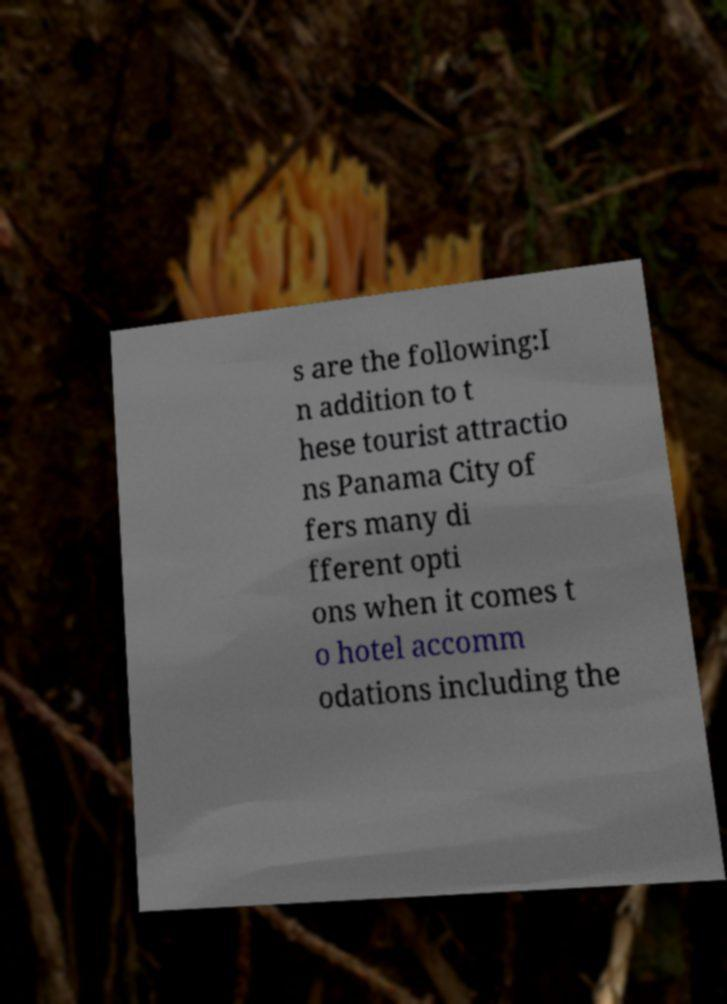Please identify and transcribe the text found in this image. s are the following:I n addition to t hese tourist attractio ns Panama City of fers many di fferent opti ons when it comes t o hotel accomm odations including the 